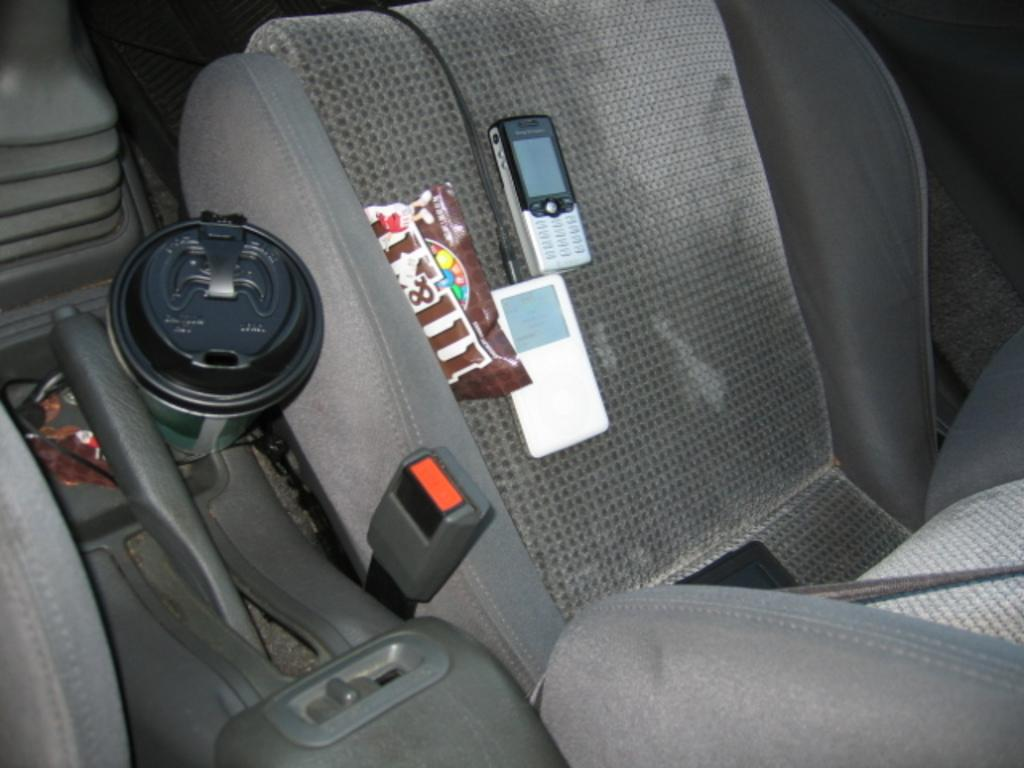What type of space is shown in the image? The image shows the interior of a vehicle. What electronic device can be seen in the image? There is a mobile phone visible in the image. What is on the seat in the image? There are objects on the seat in the image. What component of the vehicle is visible in the image? The gear rod is visible in the image. Can you describe any other objects present in the image? There are other objects present in the image. How does the jelly contribute to the functionality of the vehicle in the image? There is no jelly present in the image, so it cannot contribute to the functionality of the vehicle. 